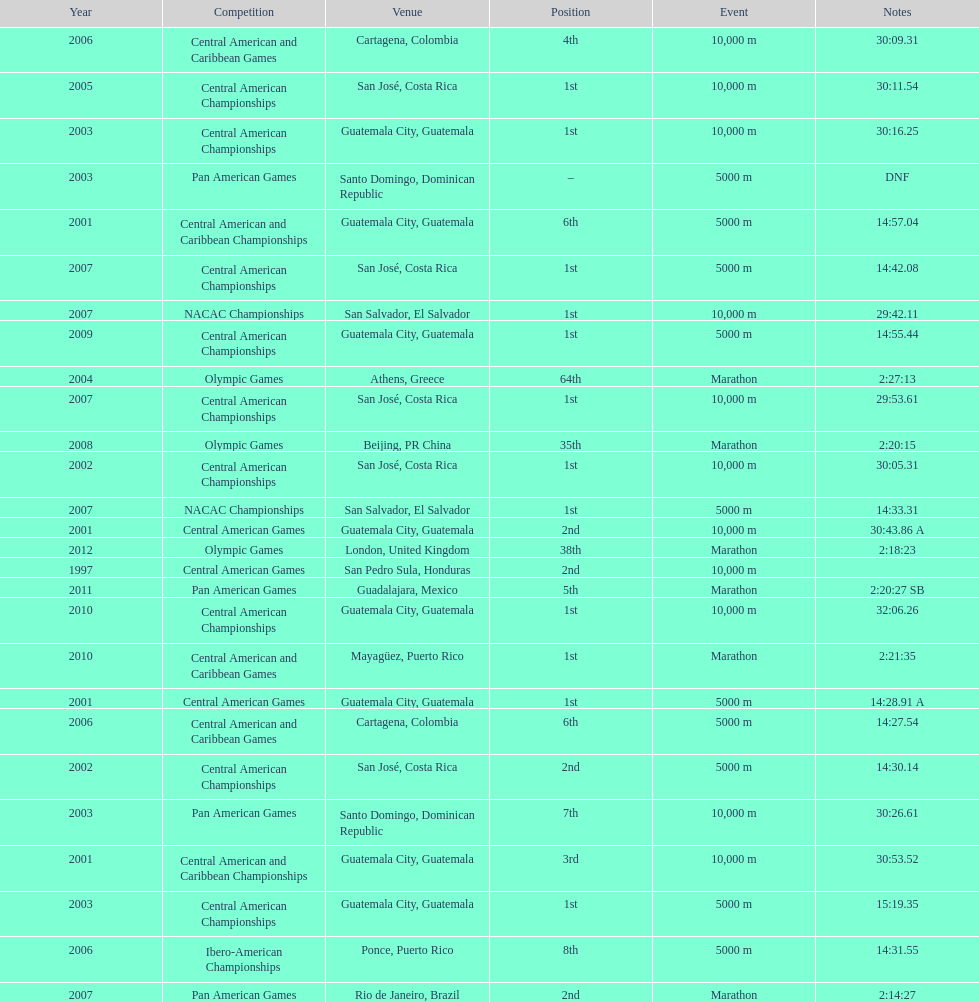At what site was the one and only 64th spot maintained? Athens, Greece. 